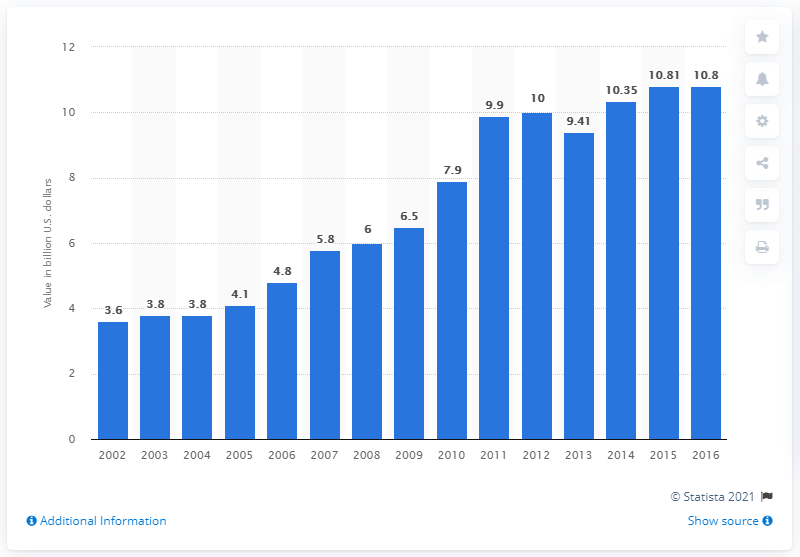Identify some key points in this picture. In 2016, the value of roasted coffee in the United States was 10.8 billion dollars. 